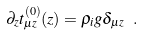<formula> <loc_0><loc_0><loc_500><loc_500>\partial _ { z } t _ { \mu z } ^ { ( 0 ) } ( z ) = \rho _ { i } g \delta _ { \mu z } \ .</formula> 